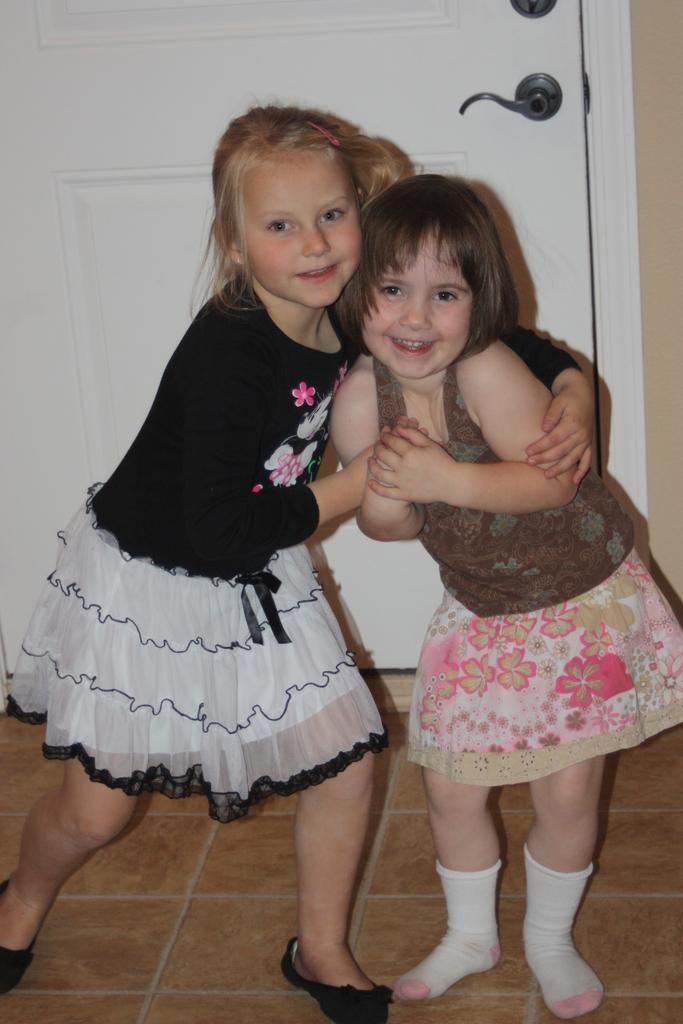Could you give a brief overview of what you see in this image? In this image in the front there are girls standing and smiling. In the background there is a door which is white in colour. 